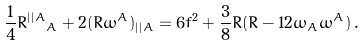Convert formula to latex. <formula><loc_0><loc_0><loc_500><loc_500>\frac { 1 } { 4 } R ^ { | | A } { _ { A } } + 2 ( R \omega ^ { A } ) _ { | | A } = 6 f ^ { 2 } + \frac { 3 } { 8 } R ( R - 1 2 \omega _ { A } \omega ^ { A } ) \, .</formula> 